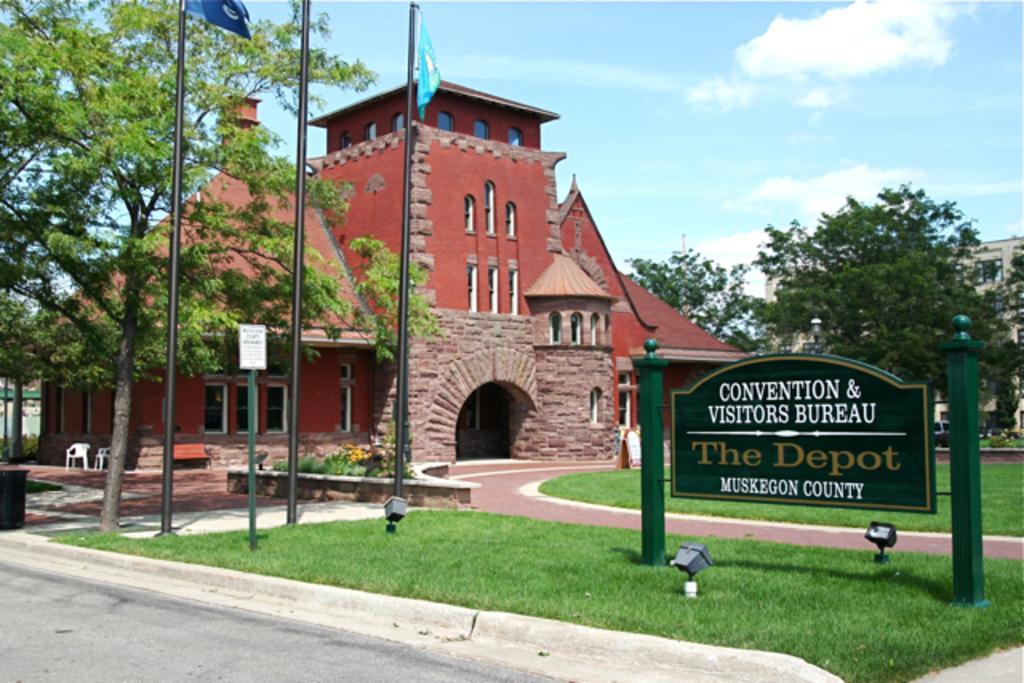Can you describe this image briefly? In this picture we can see there are green poles with a board and on the board it is written something. In front of the board there are lights on the grass and the road. On the left side of the board there are poles with flags and a small board. Behind the poles, there is a black object, chairs, a bench, plants, trees, and buildings. Behind the buildings there is the sky. 